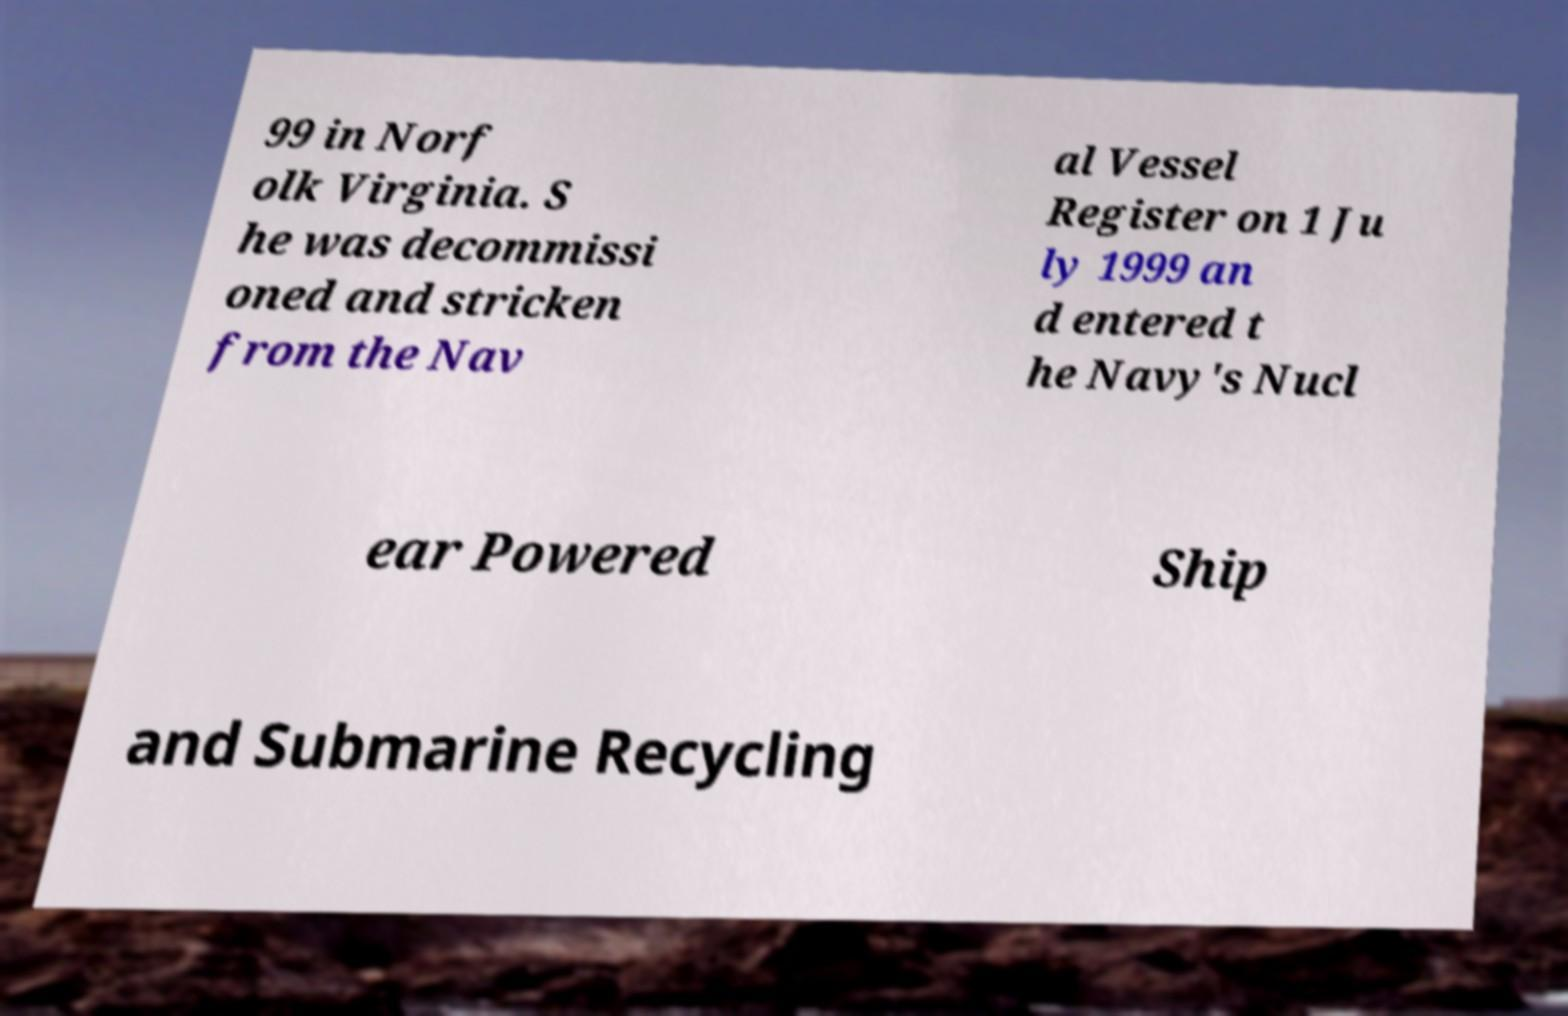Could you extract and type out the text from this image? 99 in Norf olk Virginia. S he was decommissi oned and stricken from the Nav al Vessel Register on 1 Ju ly 1999 an d entered t he Navy's Nucl ear Powered Ship and Submarine Recycling 